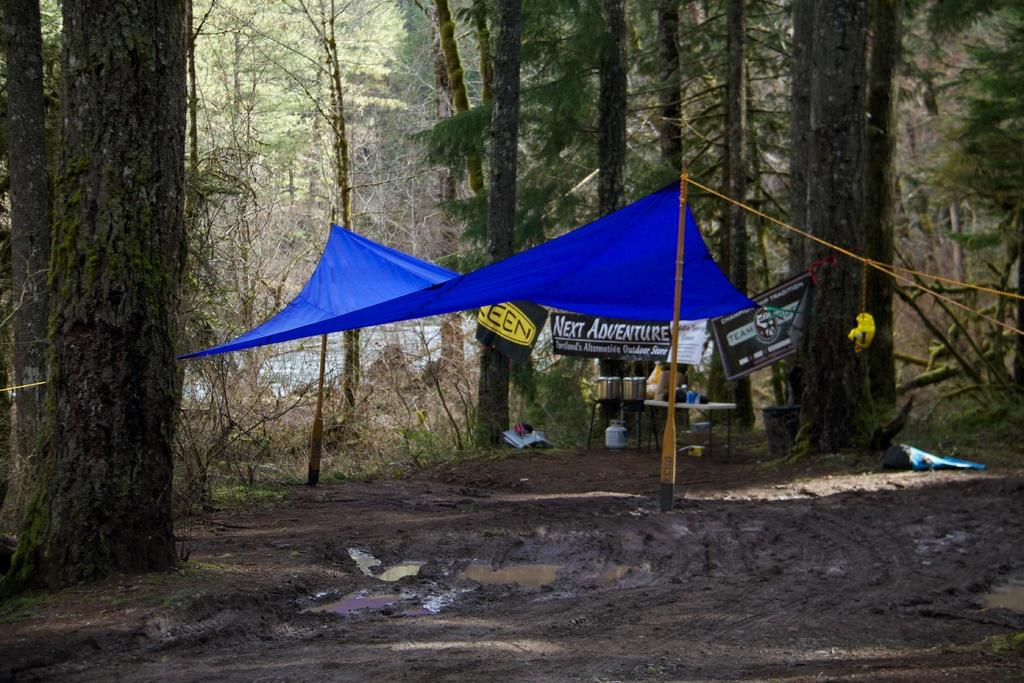What is located in the center of the image? In the center of the image, there is a cloth, boards, a pole, and a rope. Can you describe the materials used in the center of the image? The cloth appears to be made of fabric, while the boards and pole are likely made of wood. The rope is made of a flexible material. What is present at the bottom of the image? At the bottom of the image, there is mud. What can be seen in the background of the image? In the background of the image, there are trees and a pond. What type of skin can be seen on the trees in the image? There is no skin visible on the trees in the image. 